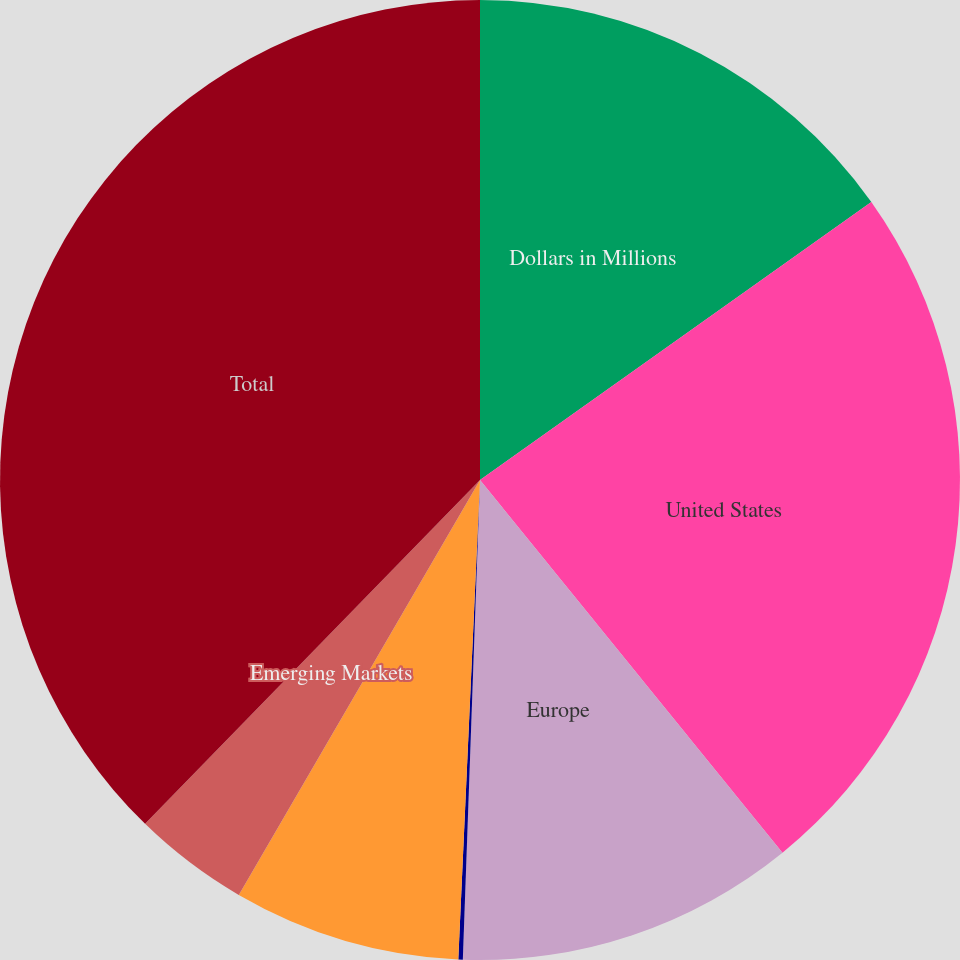Convert chart. <chart><loc_0><loc_0><loc_500><loc_500><pie_chart><fcel>Dollars in Millions<fcel>United States<fcel>Europe<fcel>Japan Asia Pacific and Canada<fcel>Latin America Middle East and<fcel>Emerging Markets<fcel>Total<nl><fcel>15.17%<fcel>23.98%<fcel>11.42%<fcel>0.15%<fcel>7.66%<fcel>3.91%<fcel>37.71%<nl></chart> 